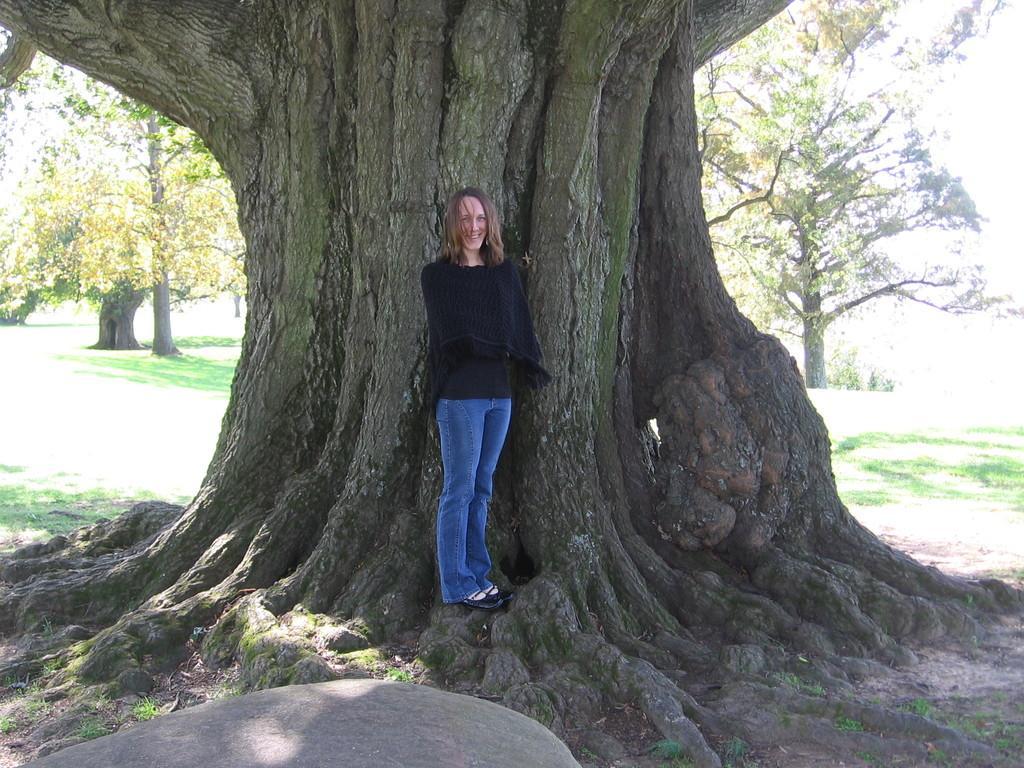Could you give a brief overview of what you see in this image? In this picture we can see a stone, woman standing and smiling and in the background we can see the grass, trees. 